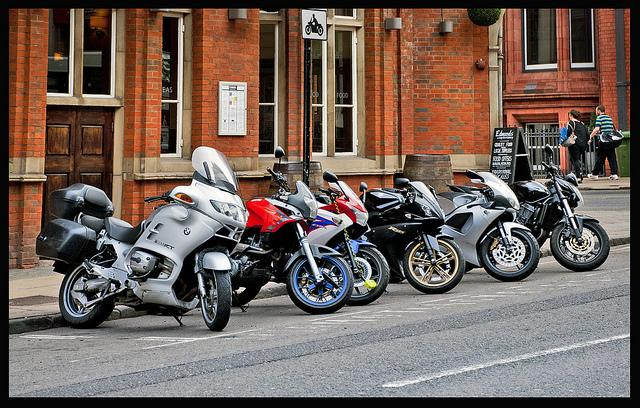What are bricks mostly made of?

Choices:
A) straw
B) sand
C) clay
D) pebbles clay 